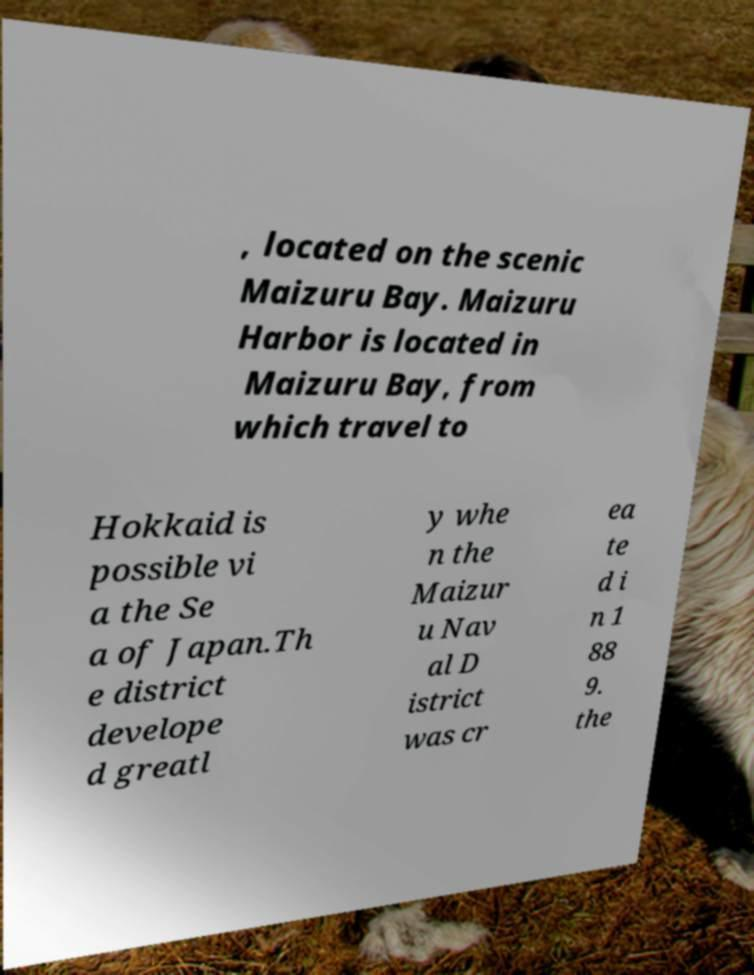Could you extract and type out the text from this image? , located on the scenic Maizuru Bay. Maizuru Harbor is located in Maizuru Bay, from which travel to Hokkaid is possible vi a the Se a of Japan.Th e district develope d greatl y whe n the Maizur u Nav al D istrict was cr ea te d i n 1 88 9. the 